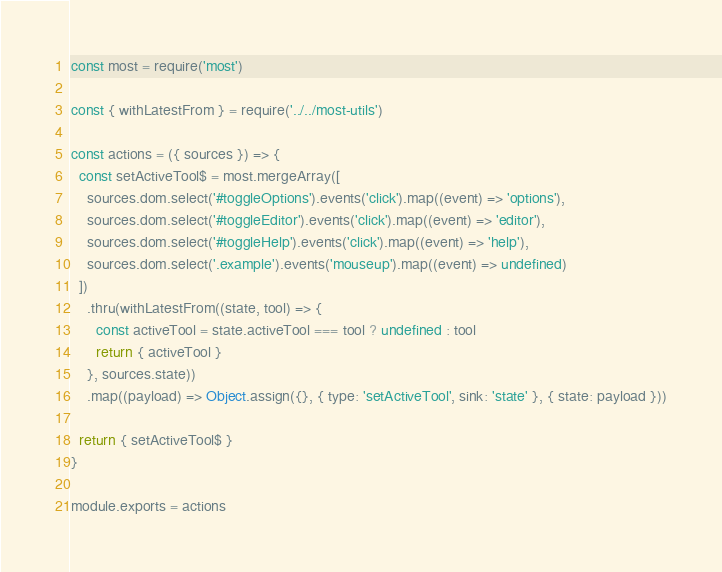Convert code to text. <code><loc_0><loc_0><loc_500><loc_500><_JavaScript_>const most = require('most')

const { withLatestFrom } = require('../../most-utils')

const actions = ({ sources }) => {
  const setActiveTool$ = most.mergeArray([
    sources.dom.select('#toggleOptions').events('click').map((event) => 'options'),
    sources.dom.select('#toggleEditor').events('click').map((event) => 'editor'),
    sources.dom.select('#toggleHelp').events('click').map((event) => 'help'),
    sources.dom.select('.example').events('mouseup').map((event) => undefined)
  ])
    .thru(withLatestFrom((state, tool) => {
      const activeTool = state.activeTool === tool ? undefined : tool
      return { activeTool }
    }, sources.state))
    .map((payload) => Object.assign({}, { type: 'setActiveTool', sink: 'state' }, { state: payload }))

  return { setActiveTool$ }
}

module.exports = actions
</code> 